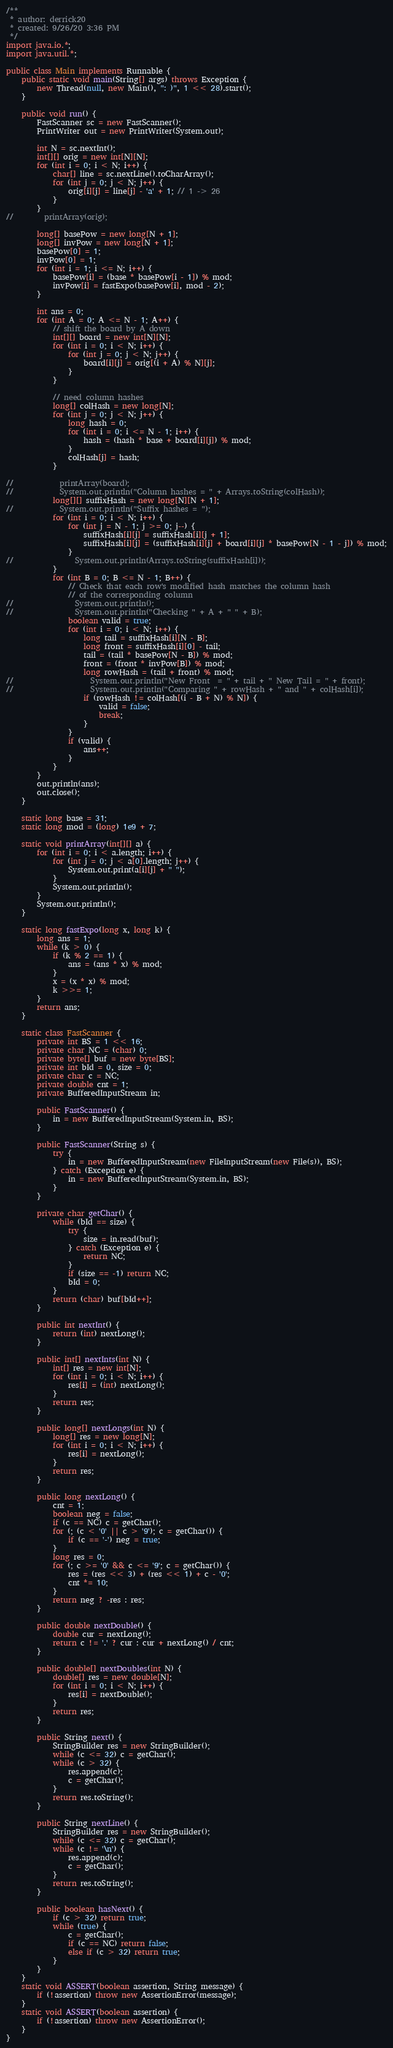Convert code to text. <code><loc_0><loc_0><loc_500><loc_500><_Java_>/**
 * author: derrick20
 * created: 9/26/20 3:36 PM
 */
import java.io.*;
import java.util.*;

public class Main implements Runnable {
    public static void main(String[] args) throws Exception {
        new Thread(null, new Main(), ": )", 1 << 28).start();
    }

    public void run() {
        FastScanner sc = new FastScanner();
        PrintWriter out = new PrintWriter(System.out);

        int N = sc.nextInt();
        int[][] orig = new int[N][N];
        for (int i = 0; i < N; i++) {
            char[] line = sc.nextLine().toCharArray();
            for (int j = 0; j < N; j++) {
                orig[i][j] = line[j] - 'a' + 1; // 1 -> 26
            }
        }
//        printArray(orig);

        long[] basePow = new long[N + 1];
        long[] invPow = new long[N + 1];
        basePow[0] = 1;
        invPow[0] = 1;
        for (int i = 1; i <= N; i++) {
            basePow[i] = (base * basePow[i - 1]) % mod;
            invPow[i] = fastExpo(basePow[i], mod - 2);
        }

        int ans = 0;
        for (int A = 0; A <= N - 1; A++) {
            // shift the board by A down
            int[][] board = new int[N][N];
            for (int i = 0; i < N; i++) {
                for (int j = 0; j < N; j++) {
                    board[i][j] = orig[(i + A) % N][j];
                }
            }

            // need column hashes
            long[] colHash = new long[N];
            for (int j = 0; j < N; j++) {
                long hash = 0;
                for (int i = 0; i <= N - 1; i++) {
                    hash = (hash * base + board[i][j]) % mod;
                }
                colHash[j] = hash;
            }

//            printArray(board);
//            System.out.println("Column hashes = " + Arrays.toString(colHash));
            long[][] suffixHash = new long[N][N + 1];
//            System.out.println("Suffix hashes = ");
            for (int i = 0; i < N; i++) {
                for (int j = N - 1; j >= 0; j--) {
                    suffixHash[i][j] = suffixHash[i][j + 1];
                    suffixHash[i][j] = (suffixHash[i][j] + board[i][j] * basePow[N - 1 - j]) % mod;
                }
//                System.out.println(Arrays.toString(suffixHash[i]));
            }
            for (int B = 0; B <= N - 1; B++) {
                // Check that each row's modified hash matches the column hash
                // of the corresponding column
//                System.out.println();
//                System.out.println("Checking " + A + " " + B);
                boolean valid = true;
                for (int i = 0; i < N; i++) {
                    long tail = suffixHash[i][N - B];
                    long front = suffixHash[i][0] - tail;
                    tail = (tail * basePow[N - B]) % mod;
                    front = (front * invPow[B]) % mod;
                    long rowHash = (tail + front) % mod;
//                    System.out.println("New Front  = " + tail + " New Tail = " + front);
//                    System.out.println("Comparing " + rowHash + " and " + colHash[i]);
                    if (rowHash != colHash[(i - B + N) % N]) {
                        valid = false;
                        break;
                    }
                }
                if (valid) {
                    ans++;
                }
            }
        }
        out.println(ans);
        out.close();
    }

    static long base = 31;
    static long mod = (long) 1e9 + 7;

    static void printArray(int[][] a) {
        for (int i = 0; i < a.length; i++) {
            for (int j = 0; j < a[0].length; j++) {
                System.out.print(a[i][j] + " ");
            }
            System.out.println();
        }
        System.out.println();
    }

    static long fastExpo(long x, long k) {
        long ans = 1;
        while (k > 0) {
            if (k % 2 == 1) {
                ans = (ans * x) % mod;
            }
            x = (x * x) % mod;
            k >>= 1;
        }
        return ans;
    }

    static class FastScanner {
        private int BS = 1 << 16;
        private char NC = (char) 0;
        private byte[] buf = new byte[BS];
        private int bId = 0, size = 0;
        private char c = NC;
        private double cnt = 1;
        private BufferedInputStream in;

        public FastScanner() {
            in = new BufferedInputStream(System.in, BS);
        }

        public FastScanner(String s) {
            try {
                in = new BufferedInputStream(new FileInputStream(new File(s)), BS);
            } catch (Exception e) {
                in = new BufferedInputStream(System.in, BS);
            }
        }

        private char getChar() {
            while (bId == size) {
                try {
                    size = in.read(buf);
                } catch (Exception e) {
                    return NC;
                }
                if (size == -1) return NC;
                bId = 0;
            }
            return (char) buf[bId++];
        }

        public int nextInt() {
            return (int) nextLong();
        }

        public int[] nextInts(int N) {
            int[] res = new int[N];
            for (int i = 0; i < N; i++) {
                res[i] = (int) nextLong();
            }
            return res;
        }

        public long[] nextLongs(int N) {
            long[] res = new long[N];
            for (int i = 0; i < N; i++) {
                res[i] = nextLong();
            }
            return res;
        }

        public long nextLong() {
            cnt = 1;
            boolean neg = false;
            if (c == NC) c = getChar();
            for (; (c < '0' || c > '9'); c = getChar()) {
                if (c == '-') neg = true;
            }
            long res = 0;
            for (; c >= '0' && c <= '9'; c = getChar()) {
                res = (res << 3) + (res << 1) + c - '0';
                cnt *= 10;
            }
            return neg ? -res : res;
        }

        public double nextDouble() {
            double cur = nextLong();
            return c != '.' ? cur : cur + nextLong() / cnt;
        }

        public double[] nextDoubles(int N) {
            double[] res = new double[N];
            for (int i = 0; i < N; i++) {
                res[i] = nextDouble();
            }
            return res;
        }

        public String next() {
            StringBuilder res = new StringBuilder();
            while (c <= 32) c = getChar();
            while (c > 32) {
                res.append(c);
                c = getChar();
            }
            return res.toString();
        }

        public String nextLine() {
            StringBuilder res = new StringBuilder();
            while (c <= 32) c = getChar();
            while (c != '\n') {
                res.append(c);
                c = getChar();
            }
            return res.toString();
        }

        public boolean hasNext() {
            if (c > 32) return true;
            while (true) {
                c = getChar();
                if (c == NC) return false;
                else if (c > 32) return true;
            }
        }
    }
    static void ASSERT(boolean assertion, String message) {
        if (!assertion) throw new AssertionError(message);
    }
    static void ASSERT(boolean assertion) {
        if (!assertion) throw new AssertionError();
    }
}</code> 